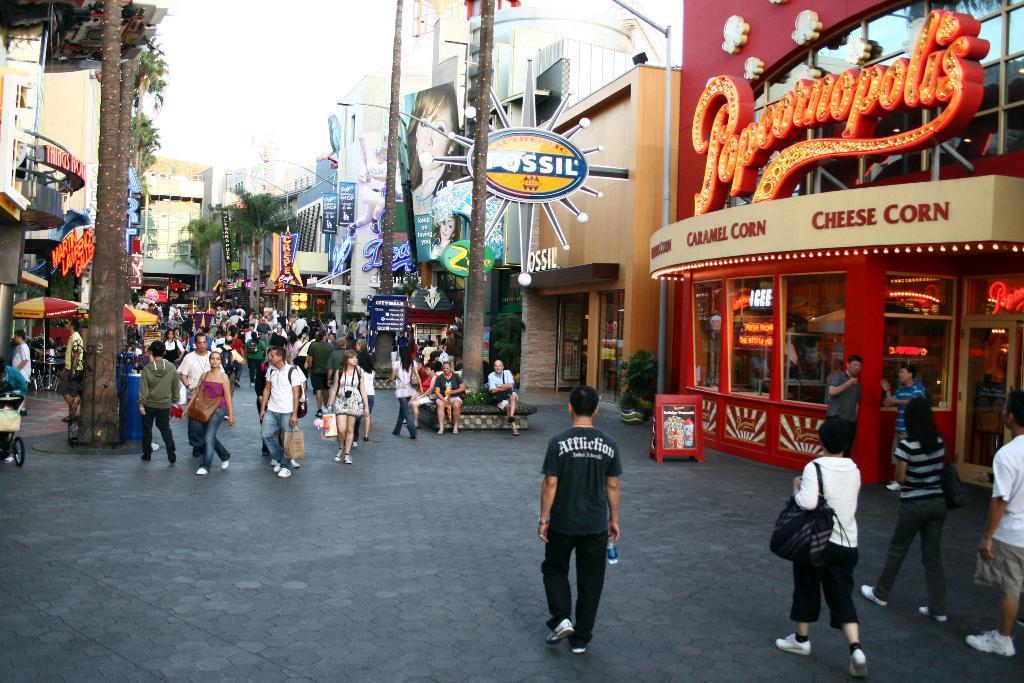In one or two sentences, can you explain what this image depicts? In this image we can see these people are walking on the road, we can see boards, trees, light poles, stores, buildings, umbrellas and the sky in the background. 